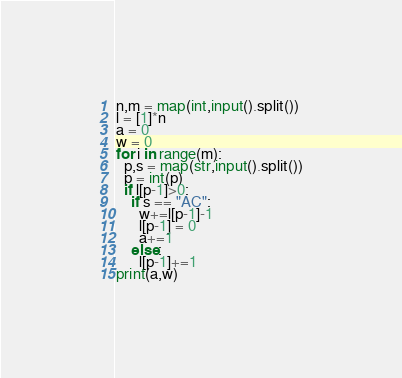Convert code to text. <code><loc_0><loc_0><loc_500><loc_500><_Python_>n,m = map(int,input().split())
l = [1]*n
a = 0
w = 0
for i in range(m):
  p,s = map(str,input().split())
  p = int(p)
  if l[p-1]>0:
    if s == "AC":
      w+=l[p-1]-1
      l[p-1] = 0
      a+=1
    else:
      l[p-1]+=1
print(a,w)</code> 